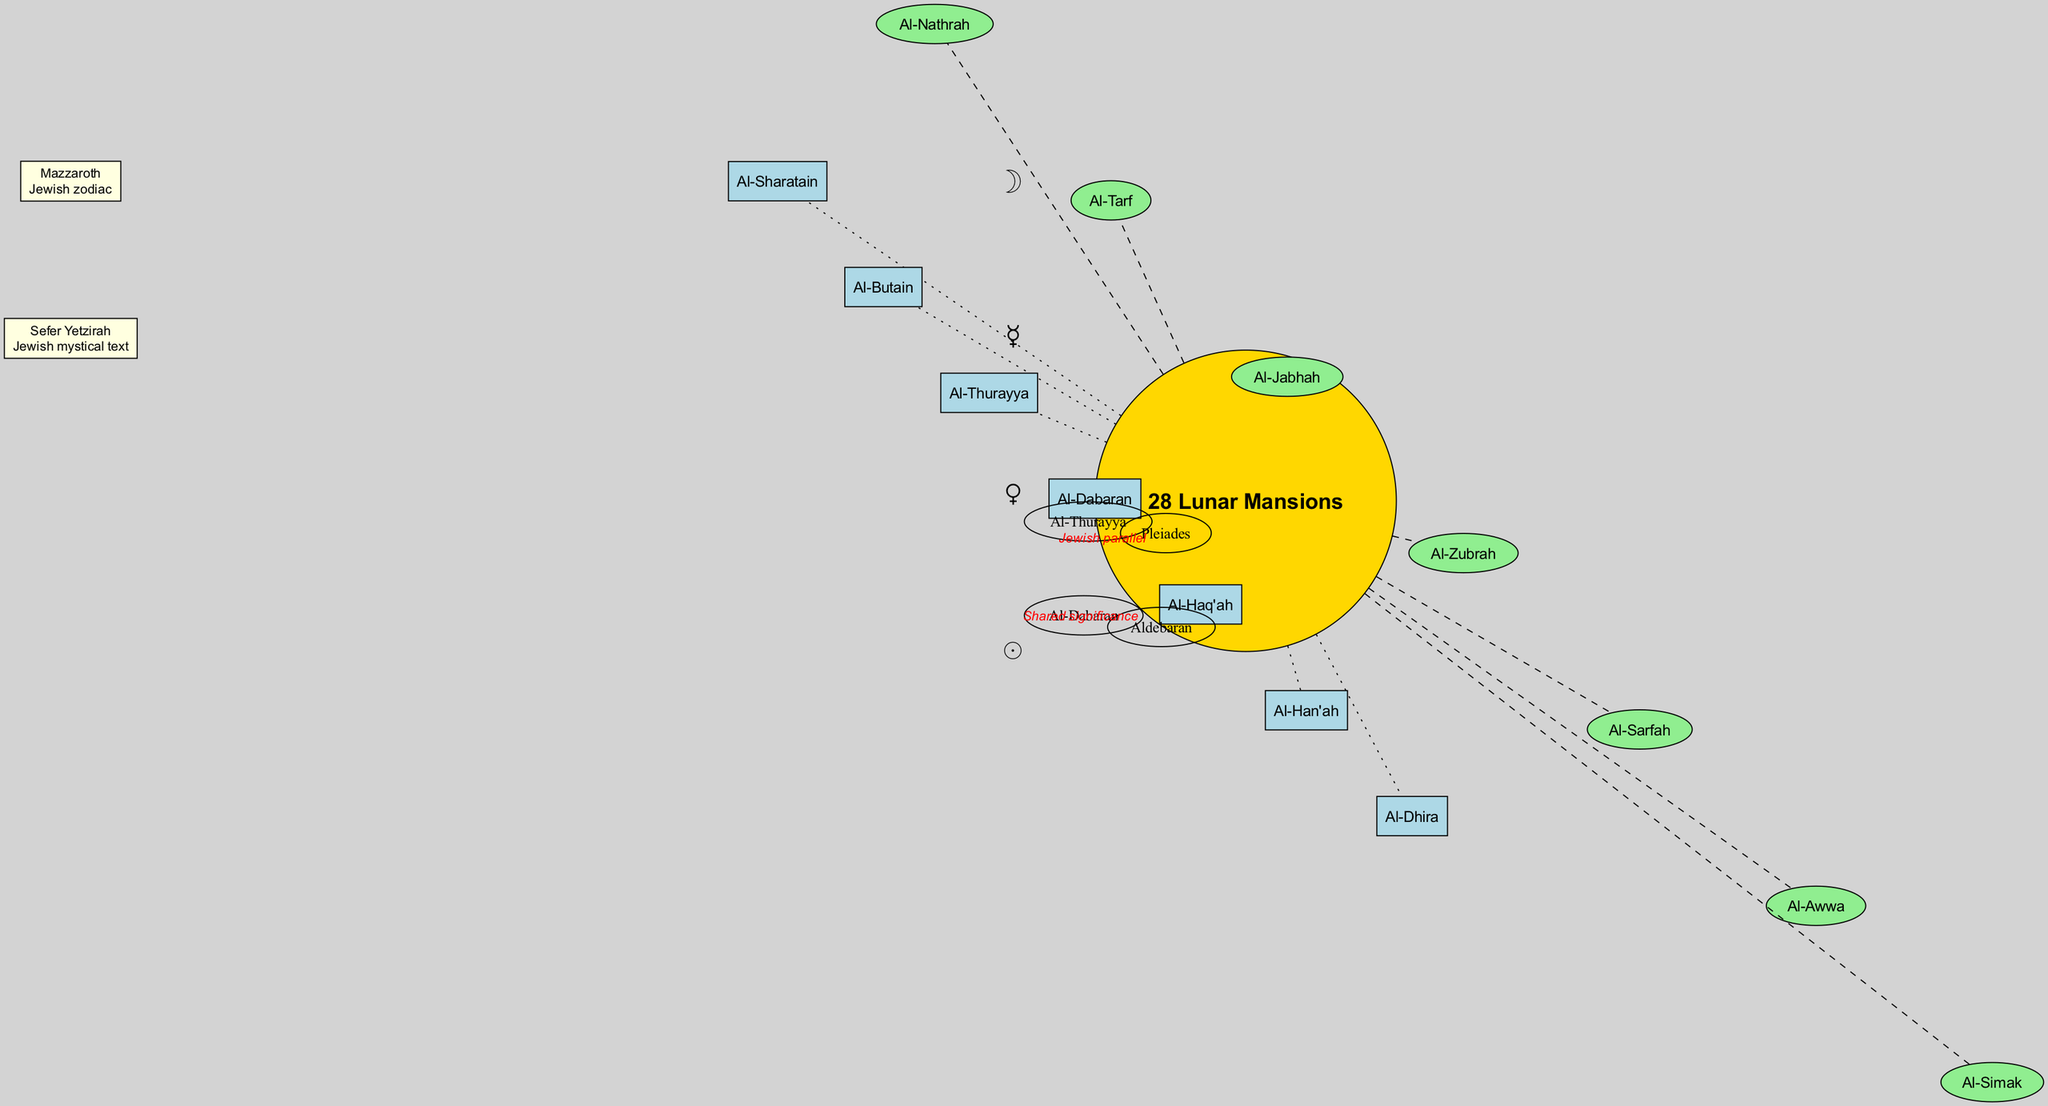What is the central node of the diagram? The central node is explicitly labeled in the diagram as "28 Lunar Mansions". This can be found in the center of the diagram, which indicates its significance as the main topic of focus.
Answer: 28 Lunar Mansions How many inner circle nodes are there? By counting the names listed in the inner circle, we determine that there are 7 nodes: Al-Sharatain, Al-Butain, Al-Thurayya, Al-Dabaran, Al-Haq'ah, Al-Han'ah, and Al-Dhira.
Answer: 7 What is the relationship between Al-Thurayya and Pleiades? The diagram specifically states that the connection from Al-Thurayya to Pleiades is labeled as "Jewish parallel". This shows a clear relationship highlighted in red.
Answer: Jewish parallel Which lunar mansion is connected to Aldebaran? The diagram identifies that Al-Dabaran is the specific lunar mansion that has a connection to Aldebaran, as indicated by the labeled edge between them.
Answer: Al-Dabaran What does Mazzaroth refer to in this context? In the diagram, Mazzaroth is described as the "Jewish zodiac" which indicates its relevance in astrology within the Jewish tradition. This context can be found in the related concepts section.
Answer: Jewish zodiac Which lunar mansion is noted for its shared significance with a star? Al-Dabaran is mentioned in the connections section as having shared significance with Aldebaran, making it the lunar mansion noted for this unique connection.
Answer: Al-Dabaran How many astrological symbols are presented in the diagram? The diagram includes 4 astrological symbols: ☽, ☿, ♀, and ☉. By counting these symbols displayed in their designated area, we can confirm their total.
Answer: 4 What color represents the inner circle nodes? The inner circle nodes are filled with the color light blue, which is mentioned in the description of the diagram when detailing how nodes are styled.
Answer: light blue Which related concept is a Jewish mystical text? The diagram lists "Sefer Yetzirah" as one of the related concepts, specifically noting it as a Jewish mystical text, which can be identified in the related concepts section.
Answer: Sefer Yetzirah 